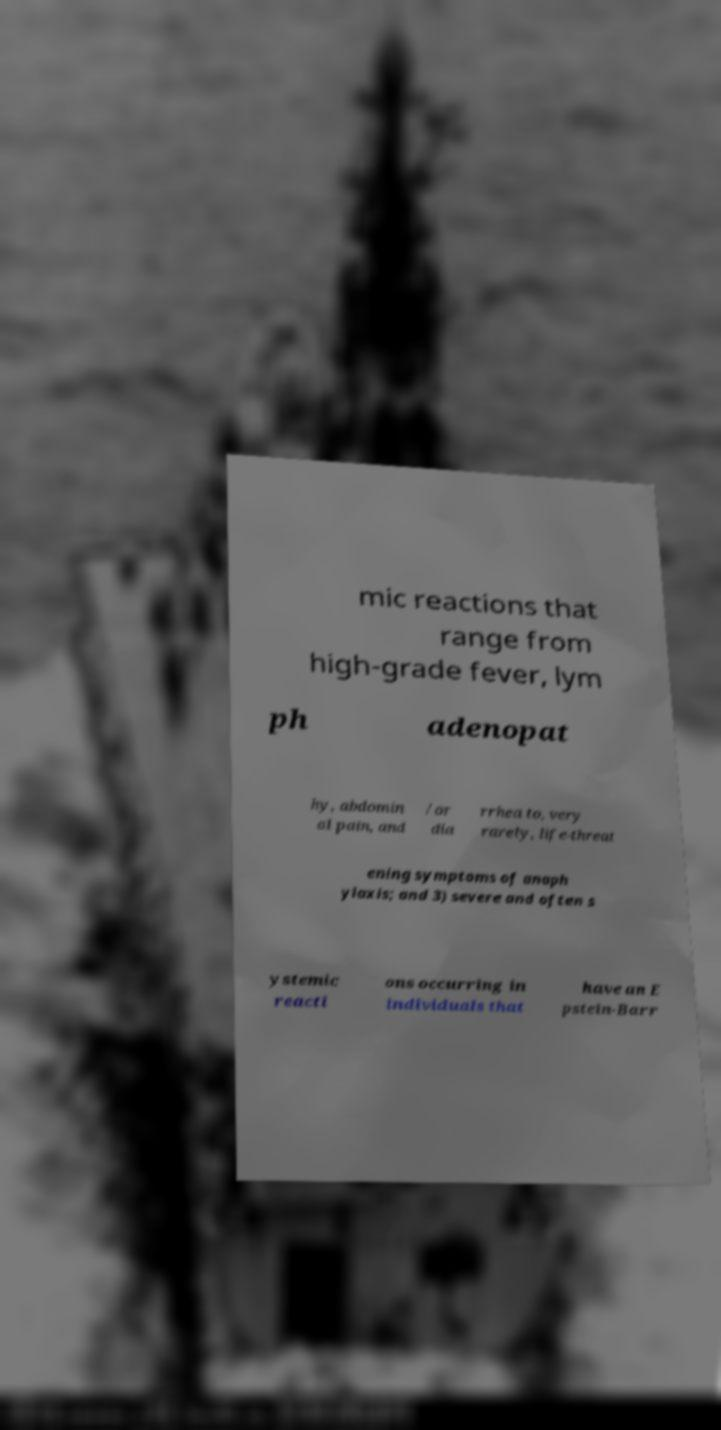Please identify and transcribe the text found in this image. mic reactions that range from high-grade fever, lym ph adenopat hy, abdomin al pain, and /or dia rrhea to, very rarely, life-threat ening symptoms of anaph ylaxis; and 3) severe and often s ystemic reacti ons occurring in individuals that have an E pstein-Barr 